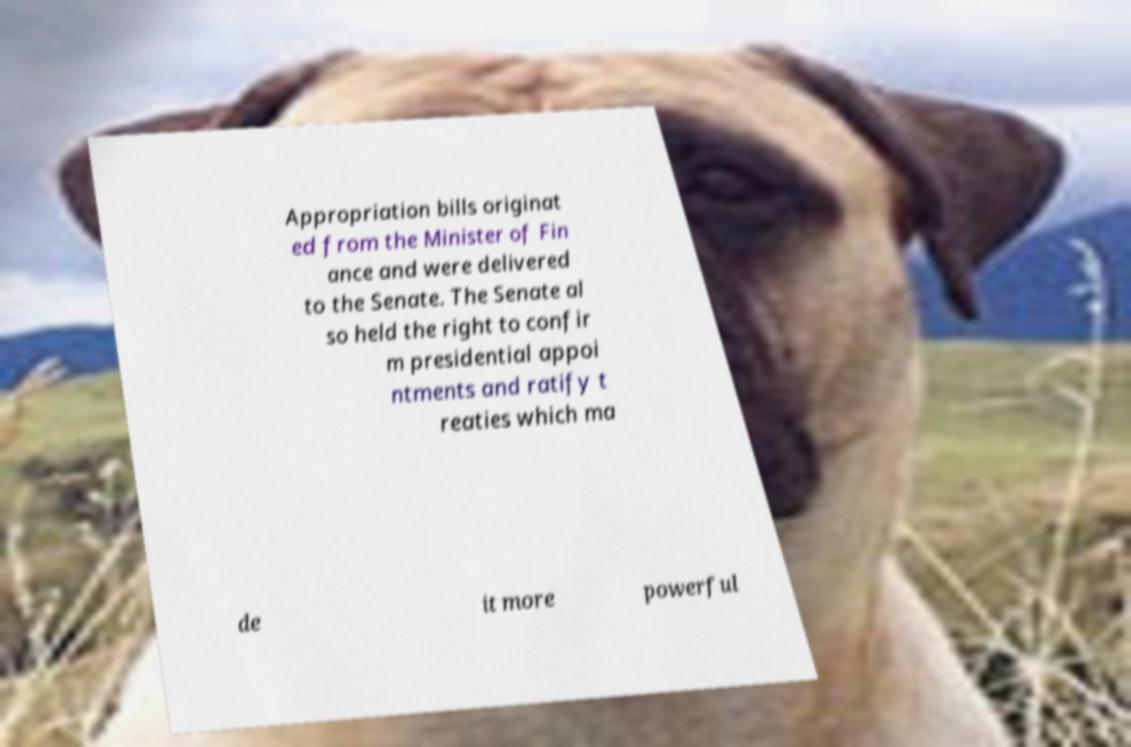Can you read and provide the text displayed in the image?This photo seems to have some interesting text. Can you extract and type it out for me? Appropriation bills originat ed from the Minister of Fin ance and were delivered to the Senate. The Senate al so held the right to confir m presidential appoi ntments and ratify t reaties which ma de it more powerful 